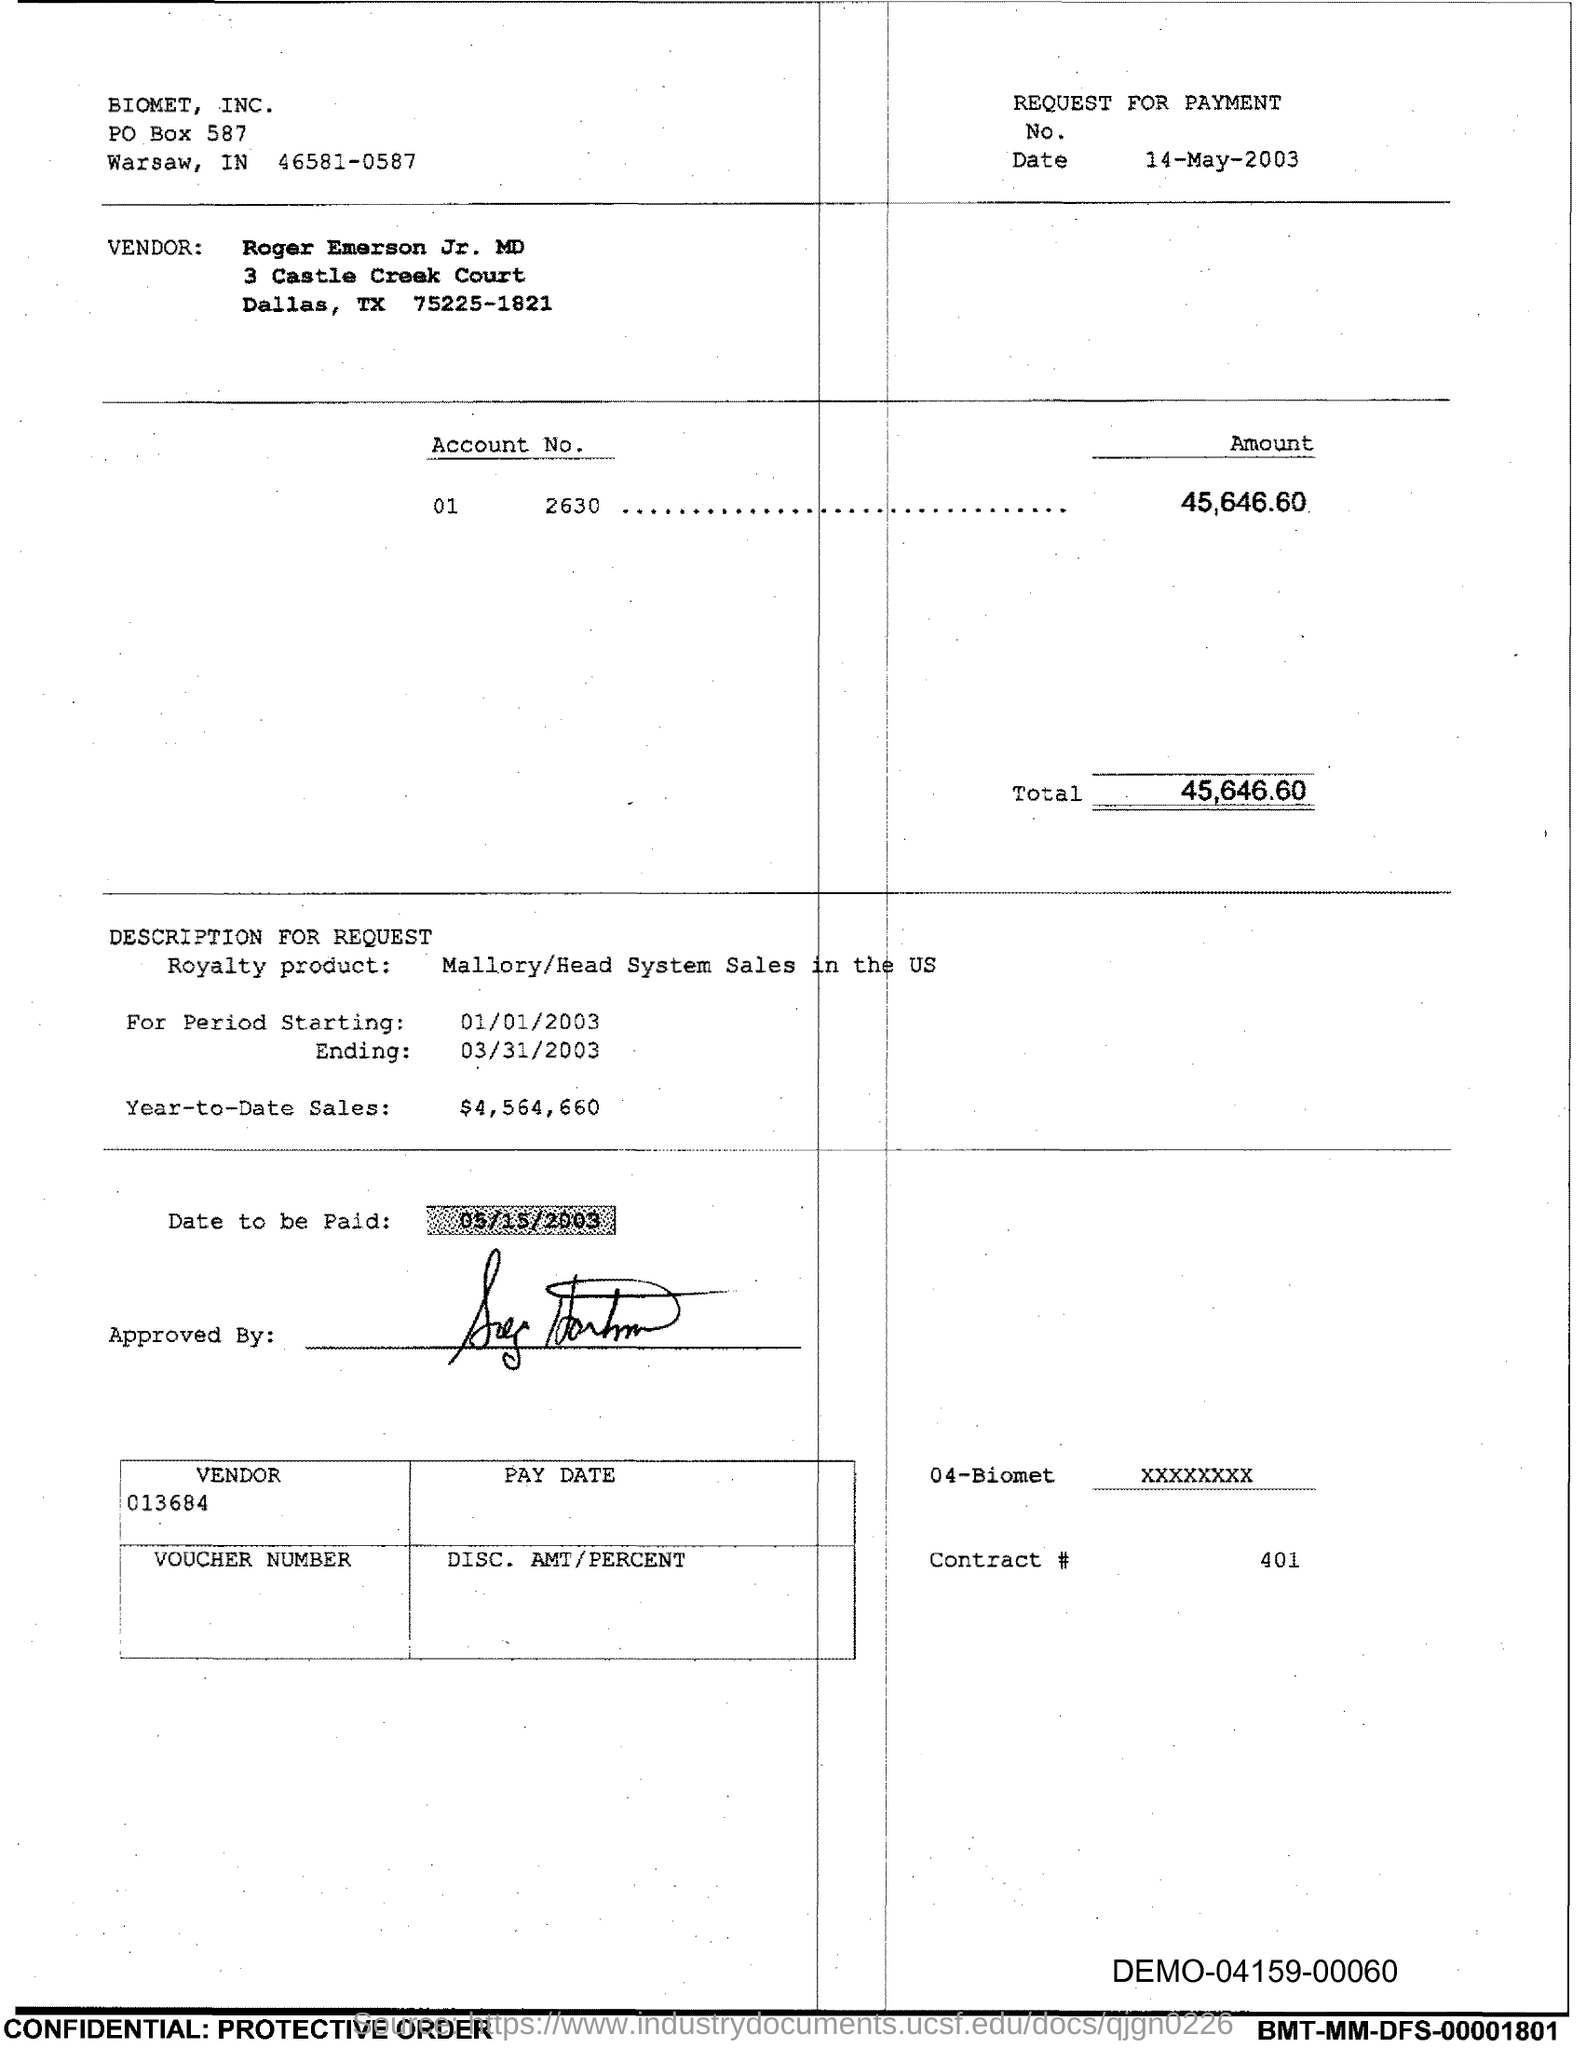List a handful of essential elements in this visual. The total is 45,646.60. 